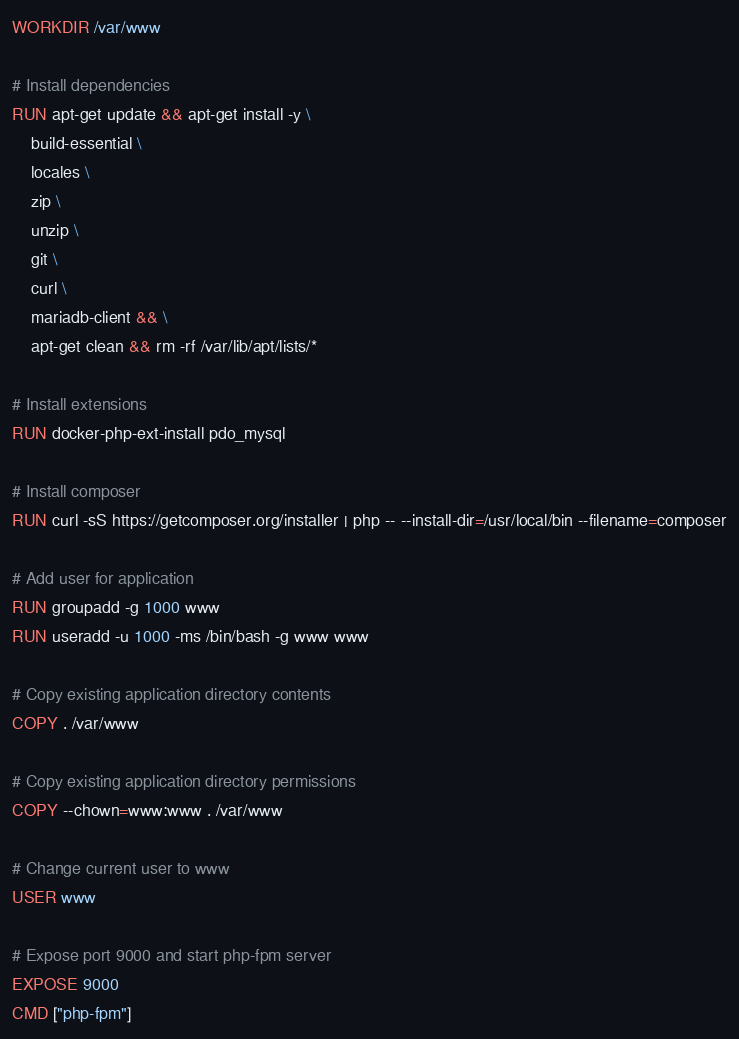Convert code to text. <code><loc_0><loc_0><loc_500><loc_500><_Dockerfile_>WORKDIR /var/www

# Install dependencies
RUN apt-get update && apt-get install -y \
    build-essential \
    locales \
    zip \
    unzip \
    git \
    curl \
    mariadb-client && \
    apt-get clean && rm -rf /var/lib/apt/lists/*

# Install extensions
RUN docker-php-ext-install pdo_mysql

# Install composer
RUN curl -sS https://getcomposer.org/installer | php -- --install-dir=/usr/local/bin --filename=composer

# Add user for application
RUN groupadd -g 1000 www
RUN useradd -u 1000 -ms /bin/bash -g www www

# Copy existing application directory contents
COPY . /var/www

# Copy existing application directory permissions
COPY --chown=www:www . /var/www

# Change current user to www
USER www

# Expose port 9000 and start php-fpm server
EXPOSE 9000
CMD ["php-fpm"]</code> 